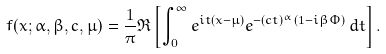<formula> <loc_0><loc_0><loc_500><loc_500>f ( x ; \alpha , \beta , c , \mu ) = { \frac { 1 } { \pi } } \Re \left [ \int _ { 0 } ^ { \infty } e ^ { i t ( x - \mu ) } e ^ { - ( c t ) ^ { \alpha } ( 1 - i \beta \Phi ) } \, d t \right ] .</formula> 